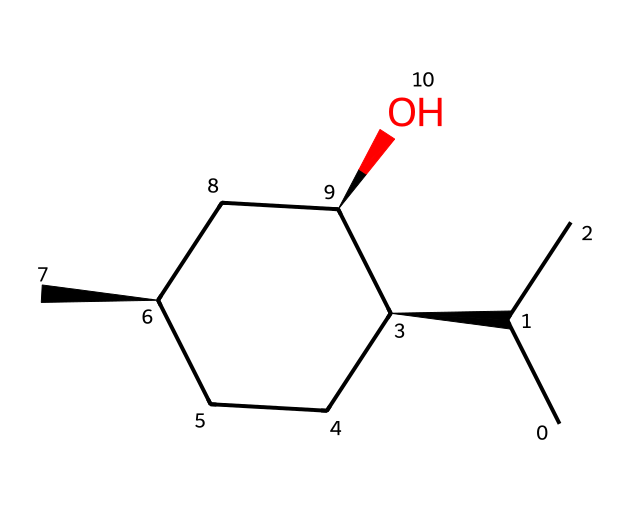What is the name of this chemical? The chemical represented by the SMILES CC(C)[C@H]1CC[C@@H](C)C[C@H]1O is known as menthol.
Answer: menthol How many chiral centers does this compound have? By examining the carbon atoms with stereochemistry indicated by the '@' symbols, there are three chiral centers in this chemical structure.
Answer: three What type of functional group is present in menthol? The presence of the -OH group indicates that menthol has a hydroxyl functional group, which is characteristic of alcohols.
Answer: hydroxyl What is the total number of carbon atoms in menthol? Counting the 'C' symbols in the SMILES reveals a total of 10 carbon atoms in the structure of menthol.
Answer: ten Which stereoisomer form is indicated in this compound? The '@' symbols in the SMILES indicate stereochemistry; thus, menthol can exist in both R and S configurations, highlighting its chiral nature.
Answer: both R and S How many hydrogen atoms are attached to menthol's structure? Each carbon in the structure generally bonds with hydrogen atoms based on the tetravalency of carbon. Summing the number of hydrogen attached, there are 20 hydrogen atoms.
Answer: twenty 